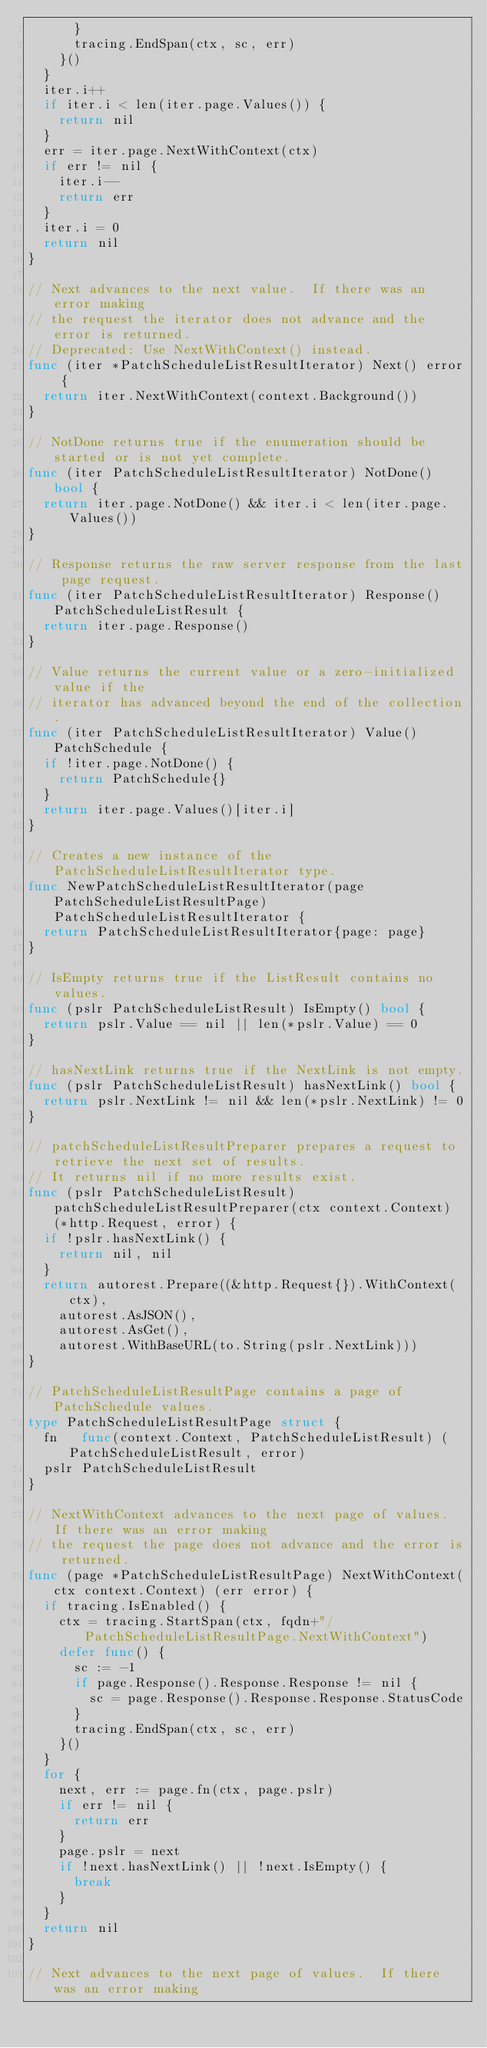<code> <loc_0><loc_0><loc_500><loc_500><_Go_>			}
			tracing.EndSpan(ctx, sc, err)
		}()
	}
	iter.i++
	if iter.i < len(iter.page.Values()) {
		return nil
	}
	err = iter.page.NextWithContext(ctx)
	if err != nil {
		iter.i--
		return err
	}
	iter.i = 0
	return nil
}

// Next advances to the next value.  If there was an error making
// the request the iterator does not advance and the error is returned.
// Deprecated: Use NextWithContext() instead.
func (iter *PatchScheduleListResultIterator) Next() error {
	return iter.NextWithContext(context.Background())
}

// NotDone returns true if the enumeration should be started or is not yet complete.
func (iter PatchScheduleListResultIterator) NotDone() bool {
	return iter.page.NotDone() && iter.i < len(iter.page.Values())
}

// Response returns the raw server response from the last page request.
func (iter PatchScheduleListResultIterator) Response() PatchScheduleListResult {
	return iter.page.Response()
}

// Value returns the current value or a zero-initialized value if the
// iterator has advanced beyond the end of the collection.
func (iter PatchScheduleListResultIterator) Value() PatchSchedule {
	if !iter.page.NotDone() {
		return PatchSchedule{}
	}
	return iter.page.Values()[iter.i]
}

// Creates a new instance of the PatchScheduleListResultIterator type.
func NewPatchScheduleListResultIterator(page PatchScheduleListResultPage) PatchScheduleListResultIterator {
	return PatchScheduleListResultIterator{page: page}
}

// IsEmpty returns true if the ListResult contains no values.
func (pslr PatchScheduleListResult) IsEmpty() bool {
	return pslr.Value == nil || len(*pslr.Value) == 0
}

// hasNextLink returns true if the NextLink is not empty.
func (pslr PatchScheduleListResult) hasNextLink() bool {
	return pslr.NextLink != nil && len(*pslr.NextLink) != 0
}

// patchScheduleListResultPreparer prepares a request to retrieve the next set of results.
// It returns nil if no more results exist.
func (pslr PatchScheduleListResult) patchScheduleListResultPreparer(ctx context.Context) (*http.Request, error) {
	if !pslr.hasNextLink() {
		return nil, nil
	}
	return autorest.Prepare((&http.Request{}).WithContext(ctx),
		autorest.AsJSON(),
		autorest.AsGet(),
		autorest.WithBaseURL(to.String(pslr.NextLink)))
}

// PatchScheduleListResultPage contains a page of PatchSchedule values.
type PatchScheduleListResultPage struct {
	fn   func(context.Context, PatchScheduleListResult) (PatchScheduleListResult, error)
	pslr PatchScheduleListResult
}

// NextWithContext advances to the next page of values.  If there was an error making
// the request the page does not advance and the error is returned.
func (page *PatchScheduleListResultPage) NextWithContext(ctx context.Context) (err error) {
	if tracing.IsEnabled() {
		ctx = tracing.StartSpan(ctx, fqdn+"/PatchScheduleListResultPage.NextWithContext")
		defer func() {
			sc := -1
			if page.Response().Response.Response != nil {
				sc = page.Response().Response.Response.StatusCode
			}
			tracing.EndSpan(ctx, sc, err)
		}()
	}
	for {
		next, err := page.fn(ctx, page.pslr)
		if err != nil {
			return err
		}
		page.pslr = next
		if !next.hasNextLink() || !next.IsEmpty() {
			break
		}
	}
	return nil
}

// Next advances to the next page of values.  If there was an error making</code> 